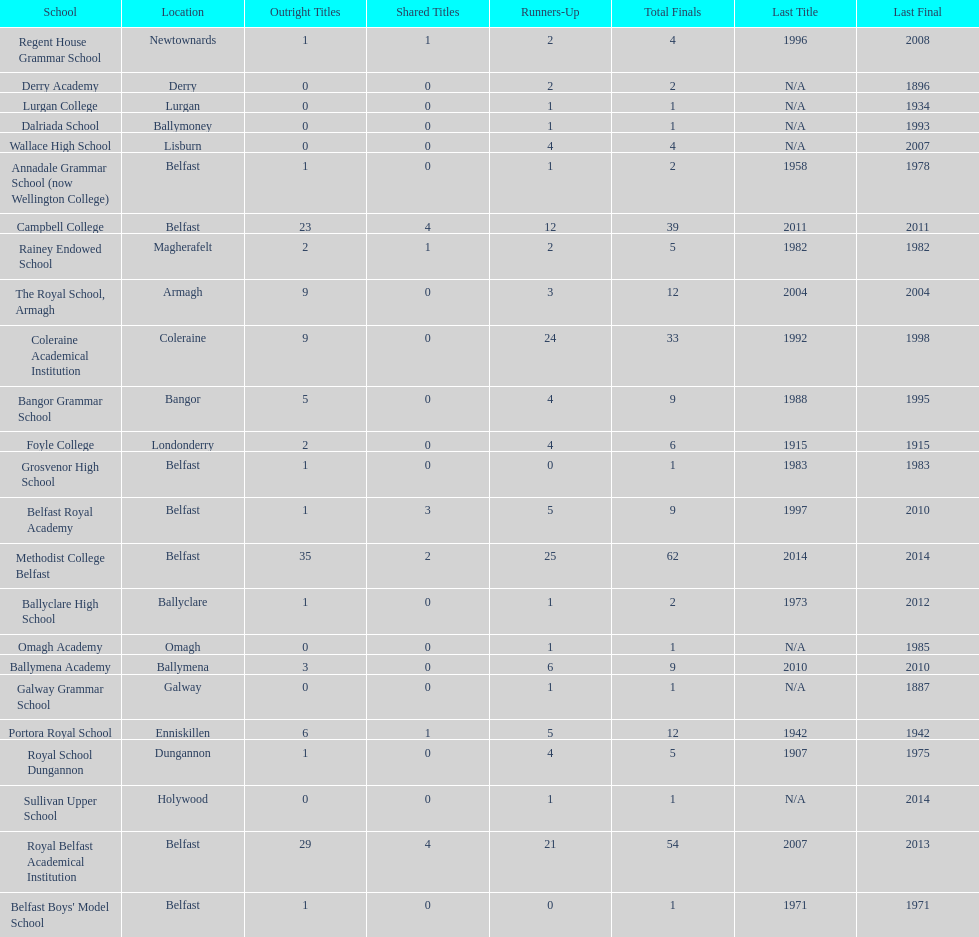How many schools have had at least 3 share titles? 3. 